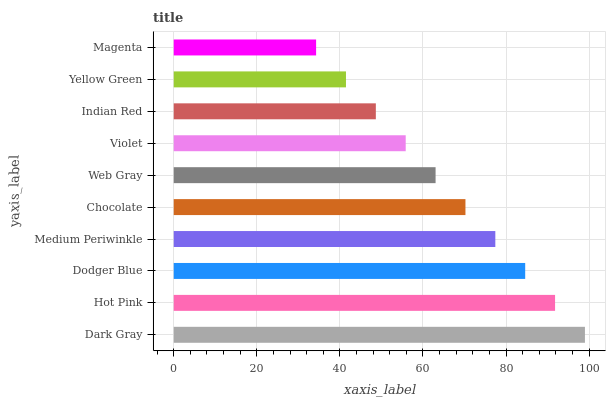Is Magenta the minimum?
Answer yes or no. Yes. Is Dark Gray the maximum?
Answer yes or no. Yes. Is Hot Pink the minimum?
Answer yes or no. No. Is Hot Pink the maximum?
Answer yes or no. No. Is Dark Gray greater than Hot Pink?
Answer yes or no. Yes. Is Hot Pink less than Dark Gray?
Answer yes or no. Yes. Is Hot Pink greater than Dark Gray?
Answer yes or no. No. Is Dark Gray less than Hot Pink?
Answer yes or no. No. Is Chocolate the high median?
Answer yes or no. Yes. Is Web Gray the low median?
Answer yes or no. Yes. Is Indian Red the high median?
Answer yes or no. No. Is Yellow Green the low median?
Answer yes or no. No. 